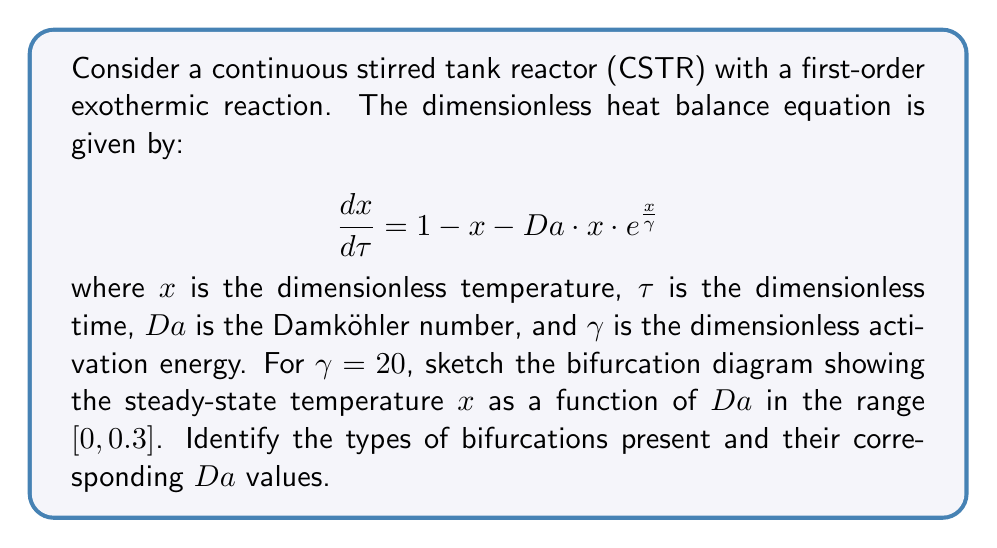Provide a solution to this math problem. To analyze the bifurcation diagram for this CSTR system, we need to follow these steps:

1. Find the steady-state solutions:
   Set $\frac{dx}{d\tau} = 0$ and solve for $x$:
   $$0 = 1 - x - Da \cdot x \cdot e^{\frac{x}{\gamma}}$$

2. This equation cannot be solved analytically, so we need to use numerical methods to find the solutions for different values of $Da$.

3. Plot the steady-state solutions $x$ vs. $Da$ for $Da \in [0, 0.3]$ and $\gamma = 20$. This can be done using a continuation method or by solving the equation for discrete $Da$ values.

4. Analyze the resulting bifurcation diagram:

   [asy]
   import graph;
   size(200,150);
   
   real f(real x, real Da) {
     return 1 - x - Da*x*exp(x/20);
   }
   
   guide g1, g2, g3;
   
   for (real Da = 0; Da <= 0.3; Da += 0.001) {
     real[] roots = rootsof(x => f(x, Da), 0, 2);
     for (real root : roots) {
       if (root >= 0 && root <= 2) {
         if (Da < 0.1604) g1 = g1--((Da, root));
         else if (Da > 0.1604 && Da < 0.2388) {
           if (root < 1) g2 = g2--((Da, root));
           else g3 = g3--((Da, root));
         }
         else g1 = g1--((Da, root));
       }
     }
   }
   
   draw(g1, blue);
   draw(g2, blue+dashed);
   draw(g3, blue);
   
   xaxis("$Da$", 0, 0.3, arrow=Arrow);
   yaxis("$x$", 0, 2, arrow=Arrow);
   
   label("$Da_1$", (0.1604, 0), S);
   label("$Da_2$", (0.2388, 0), S);
   [/asy]

5. Identify the bifurcations:
   a. Saddle-node bifurcation at $Da_1 \approx 0.1604$
   b. Saddle-node bifurcation at $Da_2 \approx 0.2388$

6. Interpret the diagram:
   - For $0 \leq Da < Da_1$: One stable steady-state (low temperature)
   - For $Da_1 < Da < Da_2$: Three steady-states (two stable, one unstable)
   - For $Da > Da_2$: One stable steady-state (high temperature)

The region between $Da_1$ and $Da_2$ exhibits hysteresis, where the system can have multiple stable states depending on its history.
Answer: Saddle-node bifurcations at $Da_1 \approx 0.1604$ and $Da_2 \approx 0.2388$ 